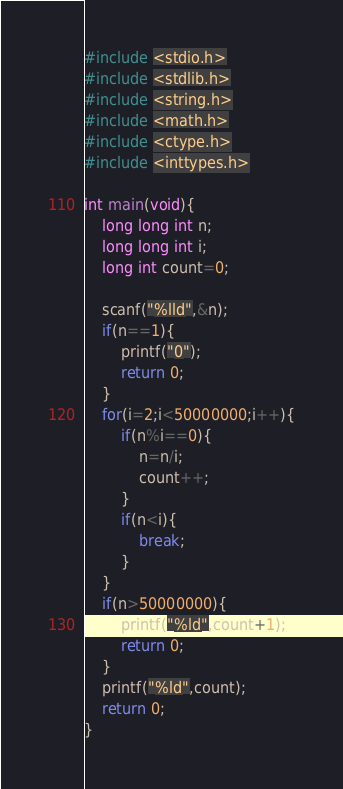Convert code to text. <code><loc_0><loc_0><loc_500><loc_500><_C_>#include <stdio.h>
#include <stdlib.h>
#include <string.h>
#include <math.h>
#include <ctype.h>
#include <inttypes.h>

int main(void){
	long long int n;
	long long int i;
	long int count=0;

	scanf("%lld",&n);
	if(n==1){
		printf("0");
		return 0;
	}
	for(i=2;i<50000000;i++){
		if(n%i==0){
			n=n/i;
			count++;
		}
		if(n<i){
			break;
		}
	}
	if(n>50000000){
		printf("%ld",count+1);
		return 0;
	}
	printf("%ld",count);
	return 0;
}
</code> 